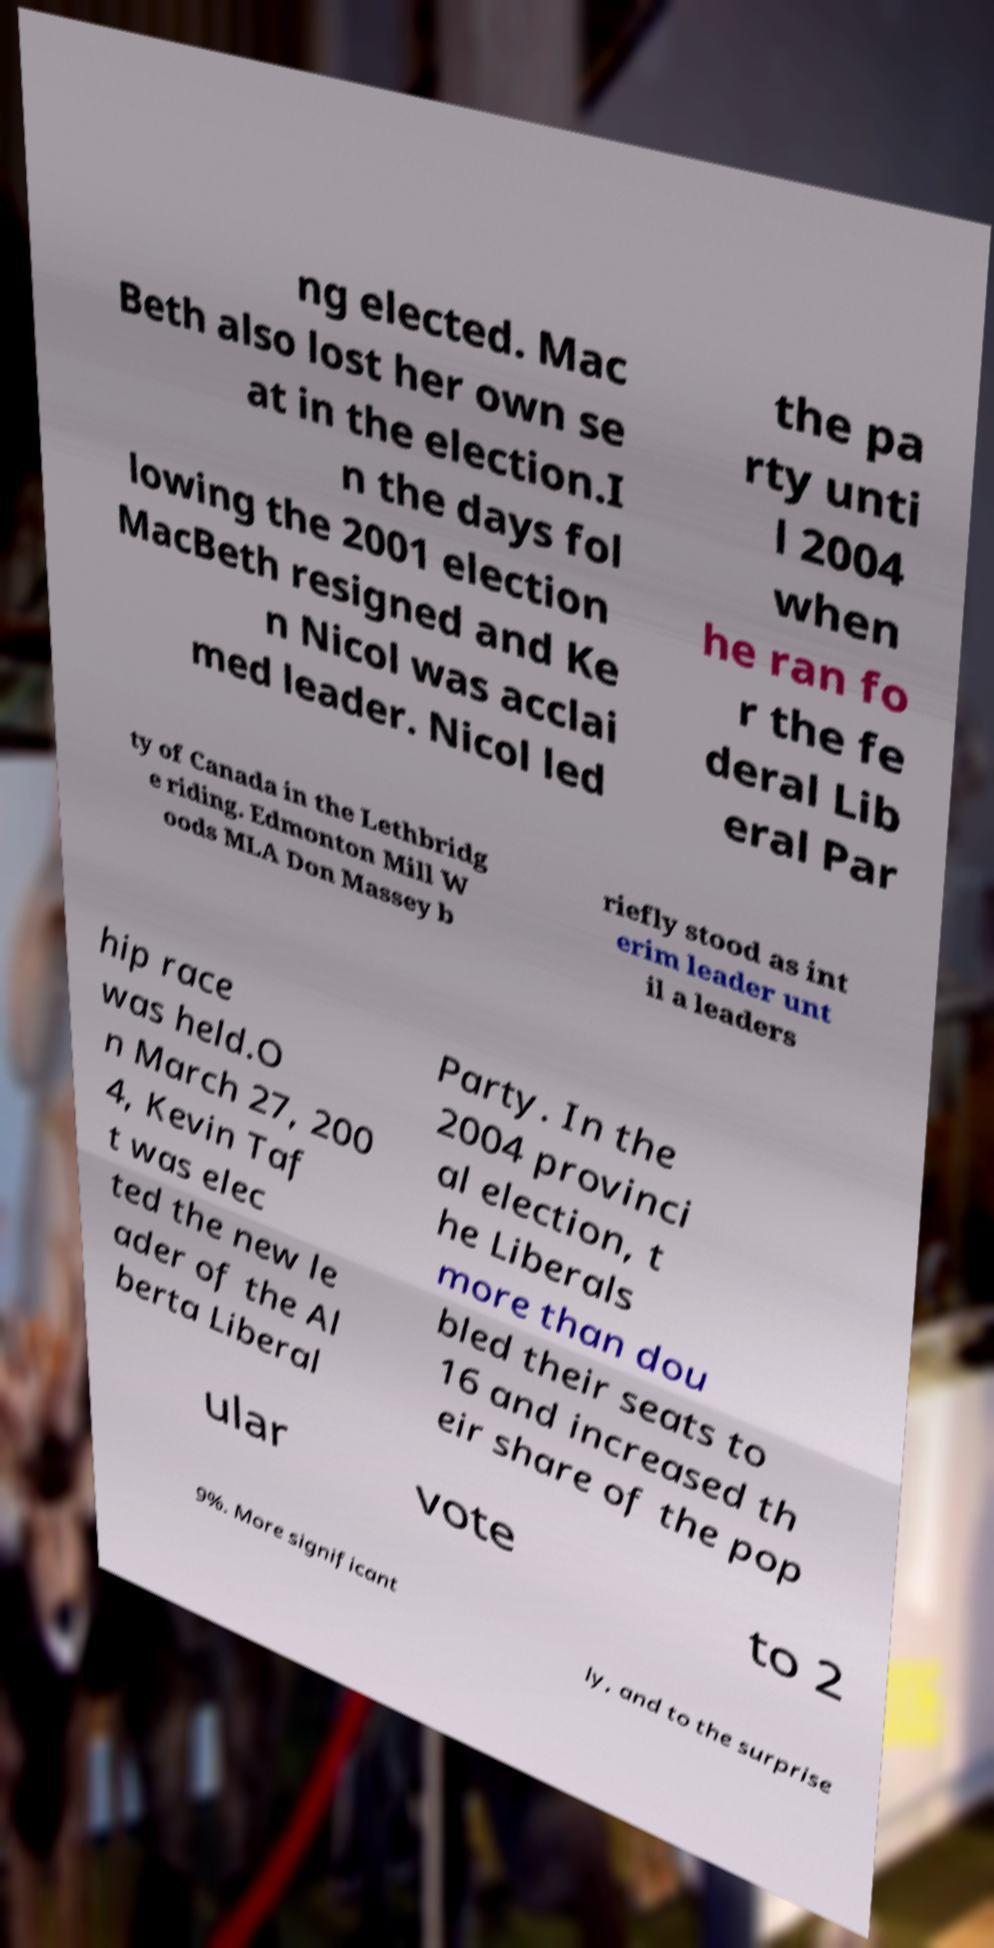Could you extract and type out the text from this image? ng elected. Mac Beth also lost her own se at in the election.I n the days fol lowing the 2001 election MacBeth resigned and Ke n Nicol was acclai med leader. Nicol led the pa rty unti l 2004 when he ran fo r the fe deral Lib eral Par ty of Canada in the Lethbridg e riding. Edmonton Mill W oods MLA Don Massey b riefly stood as int erim leader unt il a leaders hip race was held.O n March 27, 200 4, Kevin Taf t was elec ted the new le ader of the Al berta Liberal Party. In the 2004 provinci al election, t he Liberals more than dou bled their seats to 16 and increased th eir share of the pop ular vote to 2 9%. More significant ly, and to the surprise 